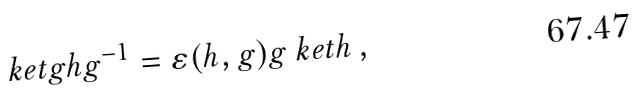Convert formula to latex. <formula><loc_0><loc_0><loc_500><loc_500>\ k e t { g h g ^ { - 1 } } = \varepsilon ( h , g ) g \ k e t { h } \, ,</formula> 